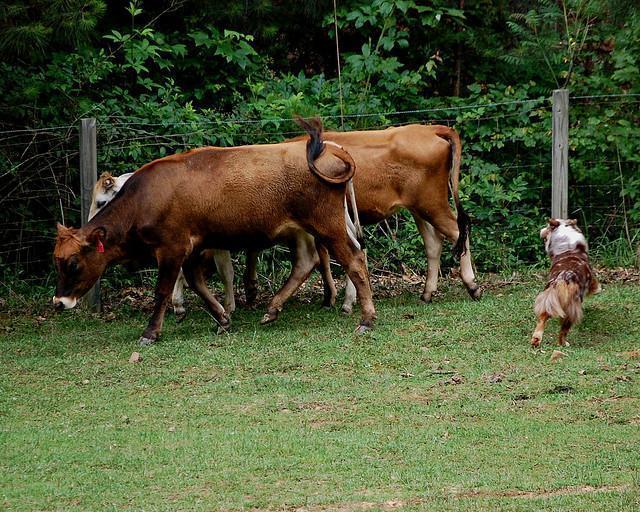How many baby buffalo are in this picture?
Give a very brief answer. 0. How many cows are visible?
Give a very brief answer. 2. 